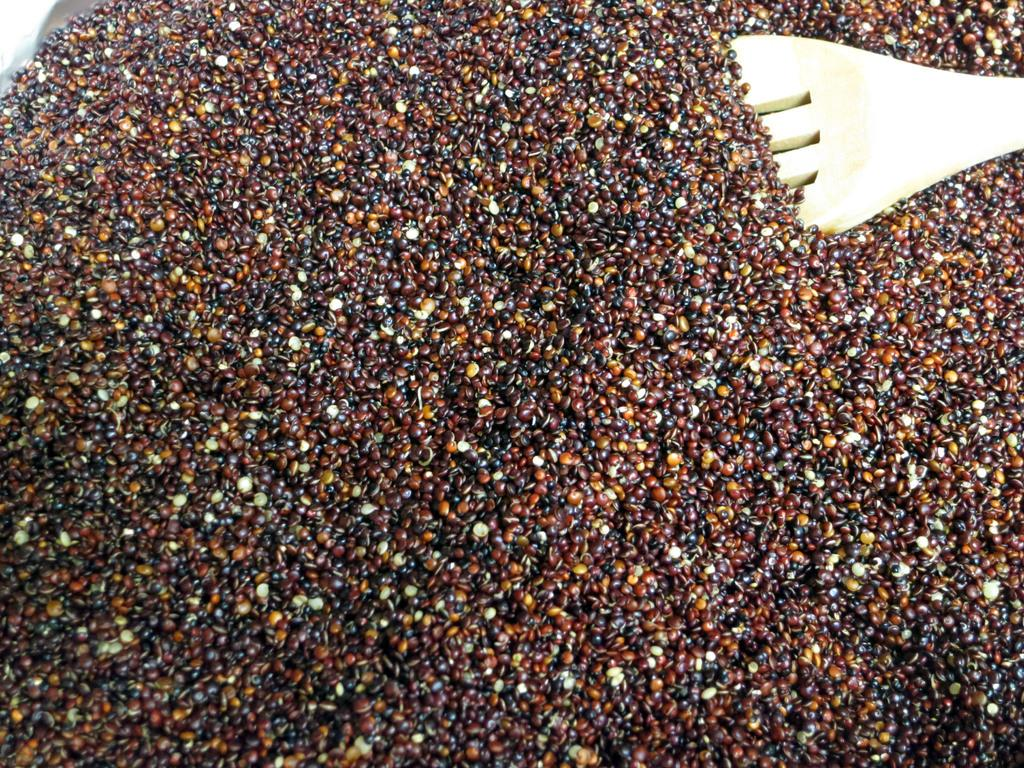What type of small objects can be seen in the image? There are seeds in the image. Can you describe the object located in the right top corner of the image? Unfortunately, the provided facts do not give any information about the object in the right top corner of the image. How many dimes are visible in the image? There is no mention of dimes in the provided facts, so we cannot determine if any are present in the image. 